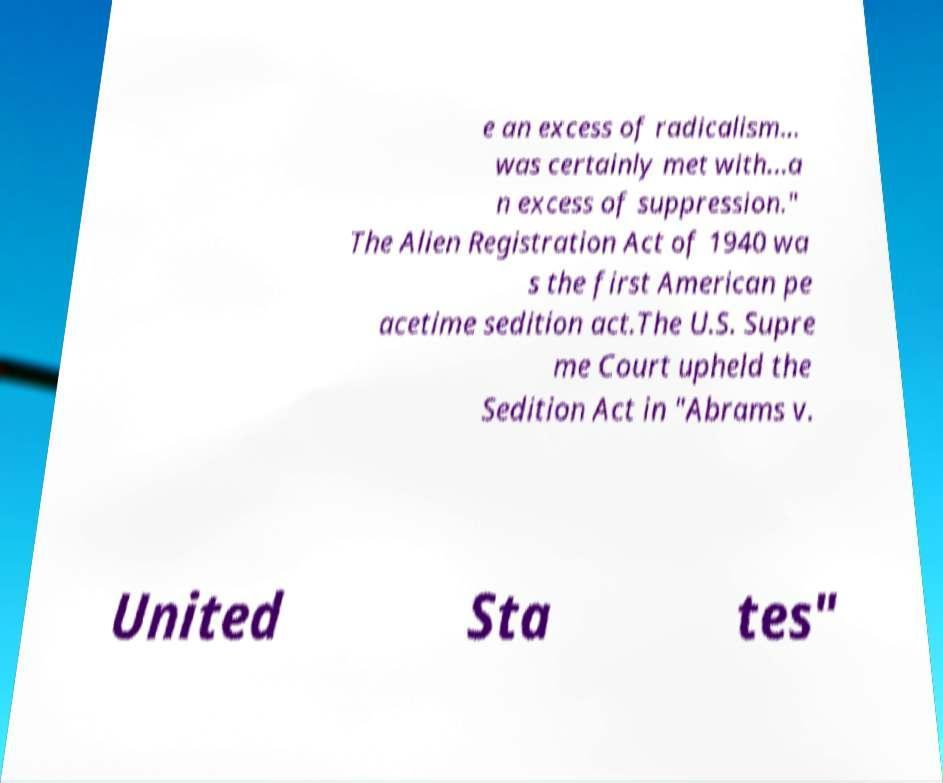What messages or text are displayed in this image? I need them in a readable, typed format. e an excess of radicalism... was certainly met with...a n excess of suppression." The Alien Registration Act of 1940 wa s the first American pe acetime sedition act.The U.S. Supre me Court upheld the Sedition Act in "Abrams v. United Sta tes" 